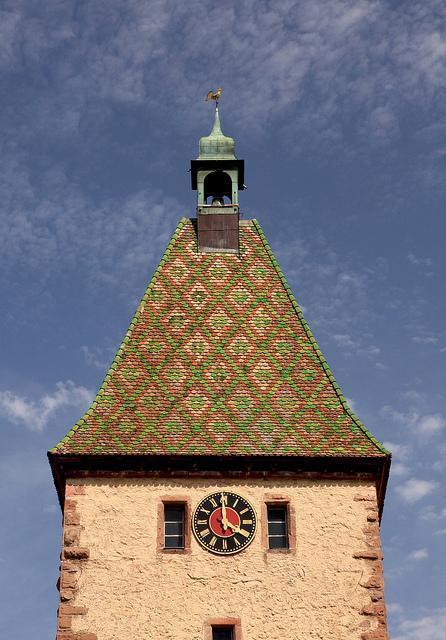How many chairs in this picture?
Give a very brief answer. 0. 